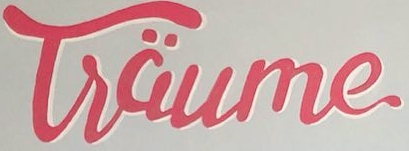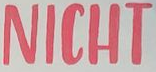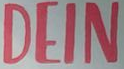What text is displayed in these images sequentially, separated by a semicolon? Tsäume; NICHT; DEIN 